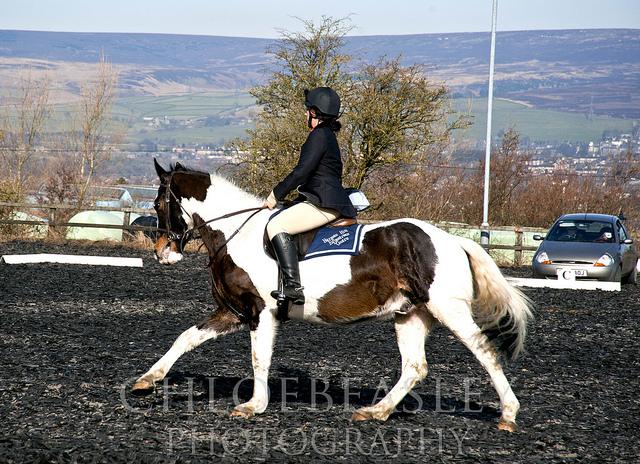Is the horse leaning to the right?
Give a very brief answer. Yes. Is this person riding with a western saddle?
Write a very short answer. No. How many cars?
Give a very brief answer. 1. What color is the horse's tail?
Write a very short answer. White. 